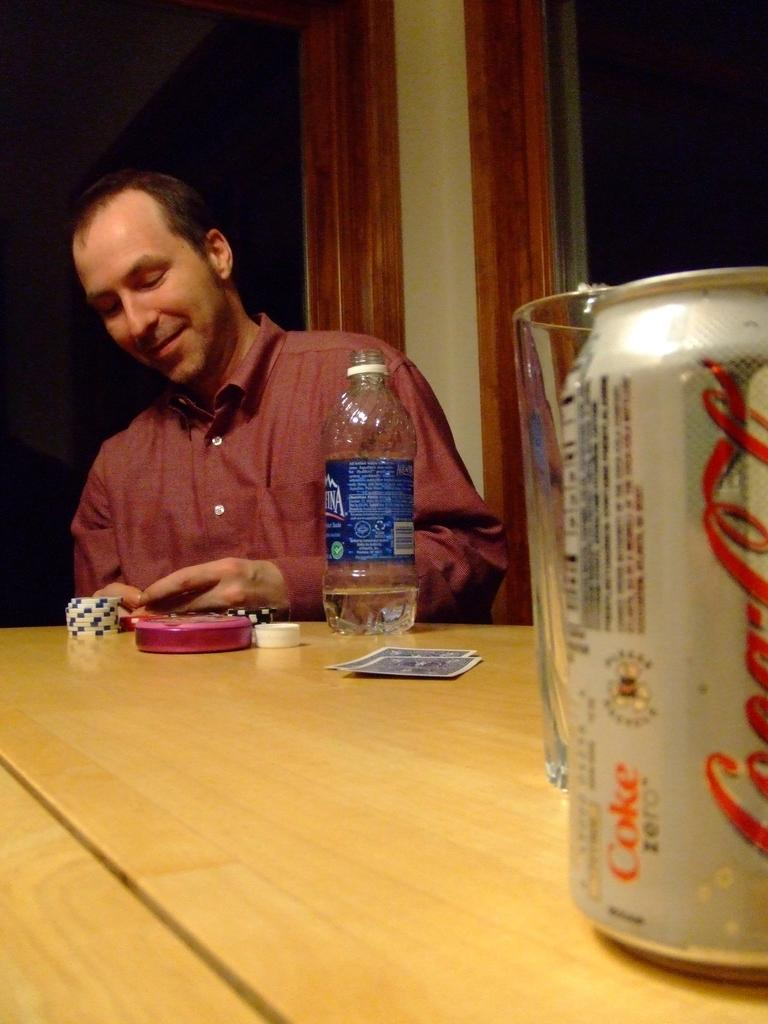<image>
Write a terse but informative summary of the picture. A bottle of water sits on the same table as a can of CocaCola. 